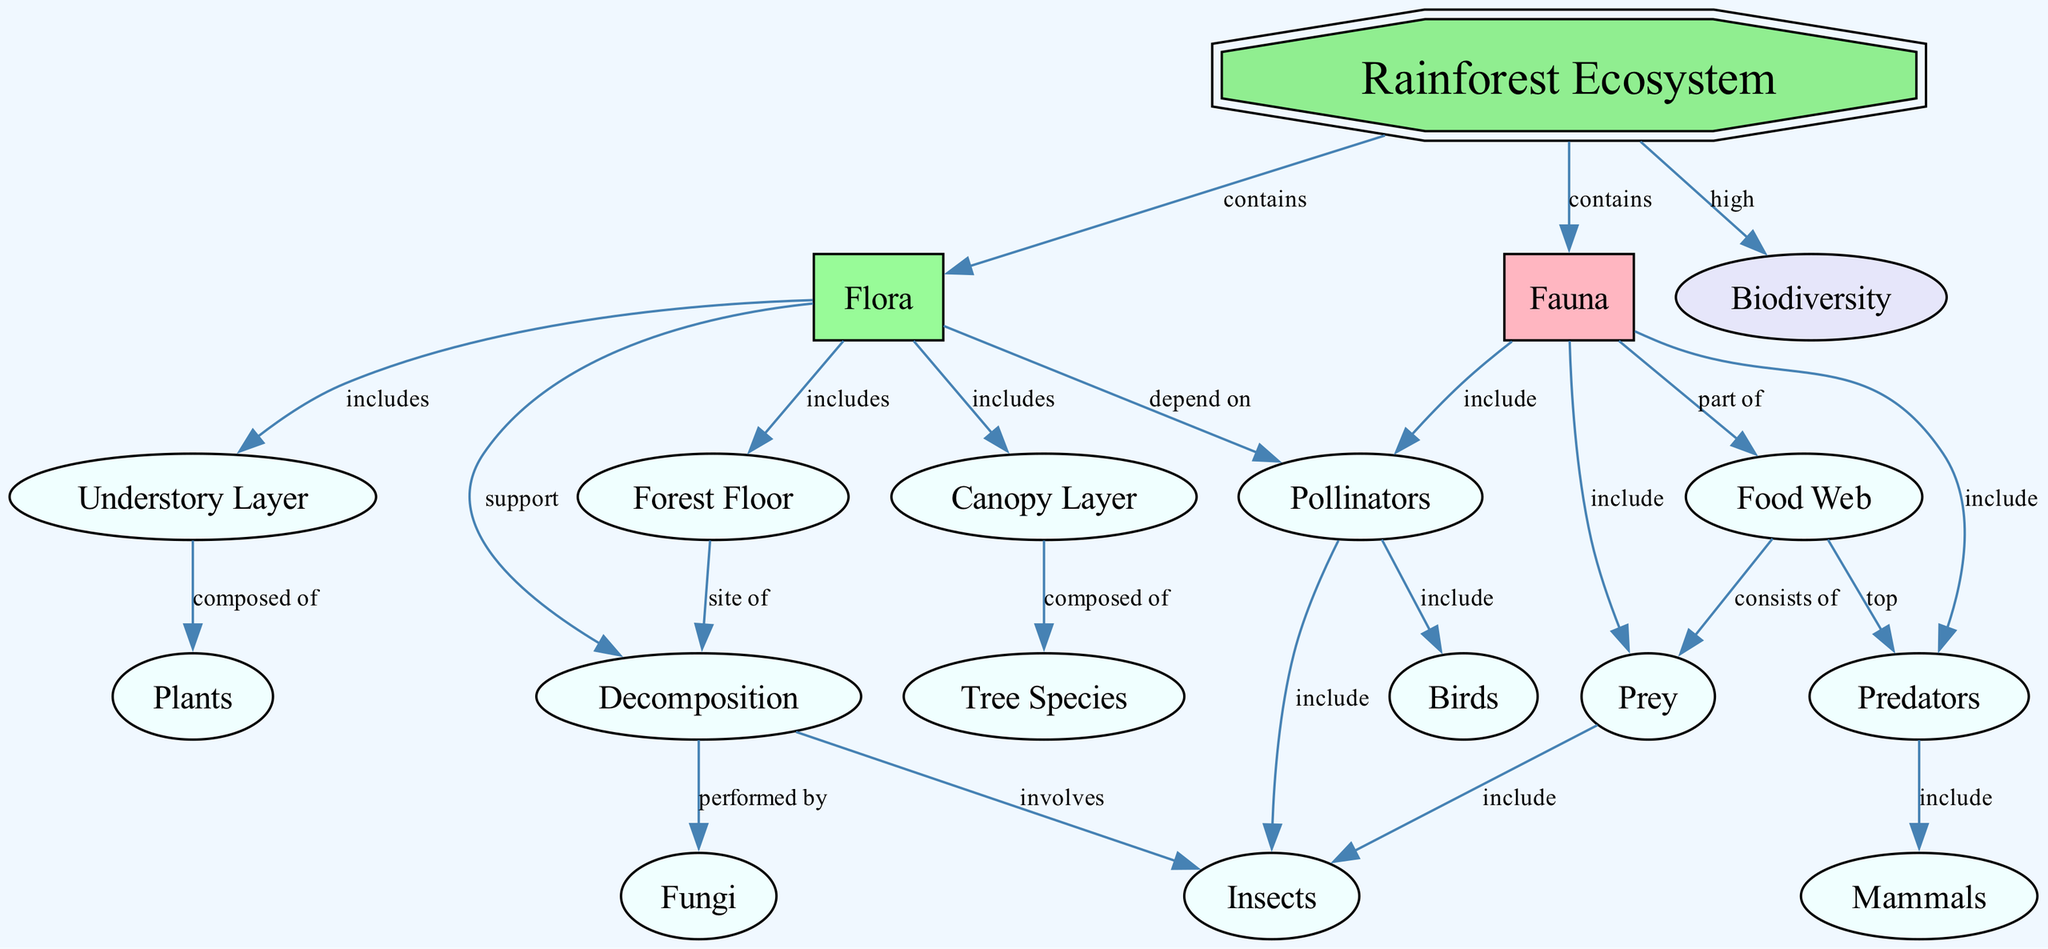What are the three layers included in flora? The diagram shows that flora includes the canopy layer, understory layer, and forest floor. These layers represent different vertical strata of vegetation within the rainforest ecosystem.
Answer: canopy layer, understory layer, forest floor Which organisms depend on pollinators? The diagram indicates that flora depends on pollinators for reproduction and other processes. This relationship shows the crucial role pollinators play in the ecosystem.
Answer: flora How many types of fauna are present in the rainforest ecosystem? The diagram mentions three types of fauna including pollinators, predators, and prey. These categories classify different roles organisms have within the ecosystem.
Answer: three What is the relationship between fauna and the food web? The diagram illustrates that fauna is part of the food web, indicating that these organisms contribute to the various trophic levels and interactions in the ecosystem.
Answer: part of Which layer is composed of tree species? According to the diagram, the canopy layer is specifically composed of tree species, showing its significance in the vertical structure of the rainforest.
Answer: canopy layer What is performed by decomposition? The diagram identifies that decomposition is performed by fungi, highlighting its role in recycling nutrients within the ecosystem.
Answer: fungi What category does the forest floor support? The diagram shows that the forest floor is the site of decomposition, indicating its function in breaking down organic matter and enriching soil fertility.
Answer: decomposition Which layer is composed of plants? The understory layer is shown to be composed of plants, reflecting its role in supporting biodiversity and providing habitat within the ecosystem.
Answer: understory layer How do prey relate to insects in the food web? The diagram specifies that prey includes insects, indicating a direct connection in food chains where insects serve as a vital food resource for various predators in the ecosystem.
Answer: include 